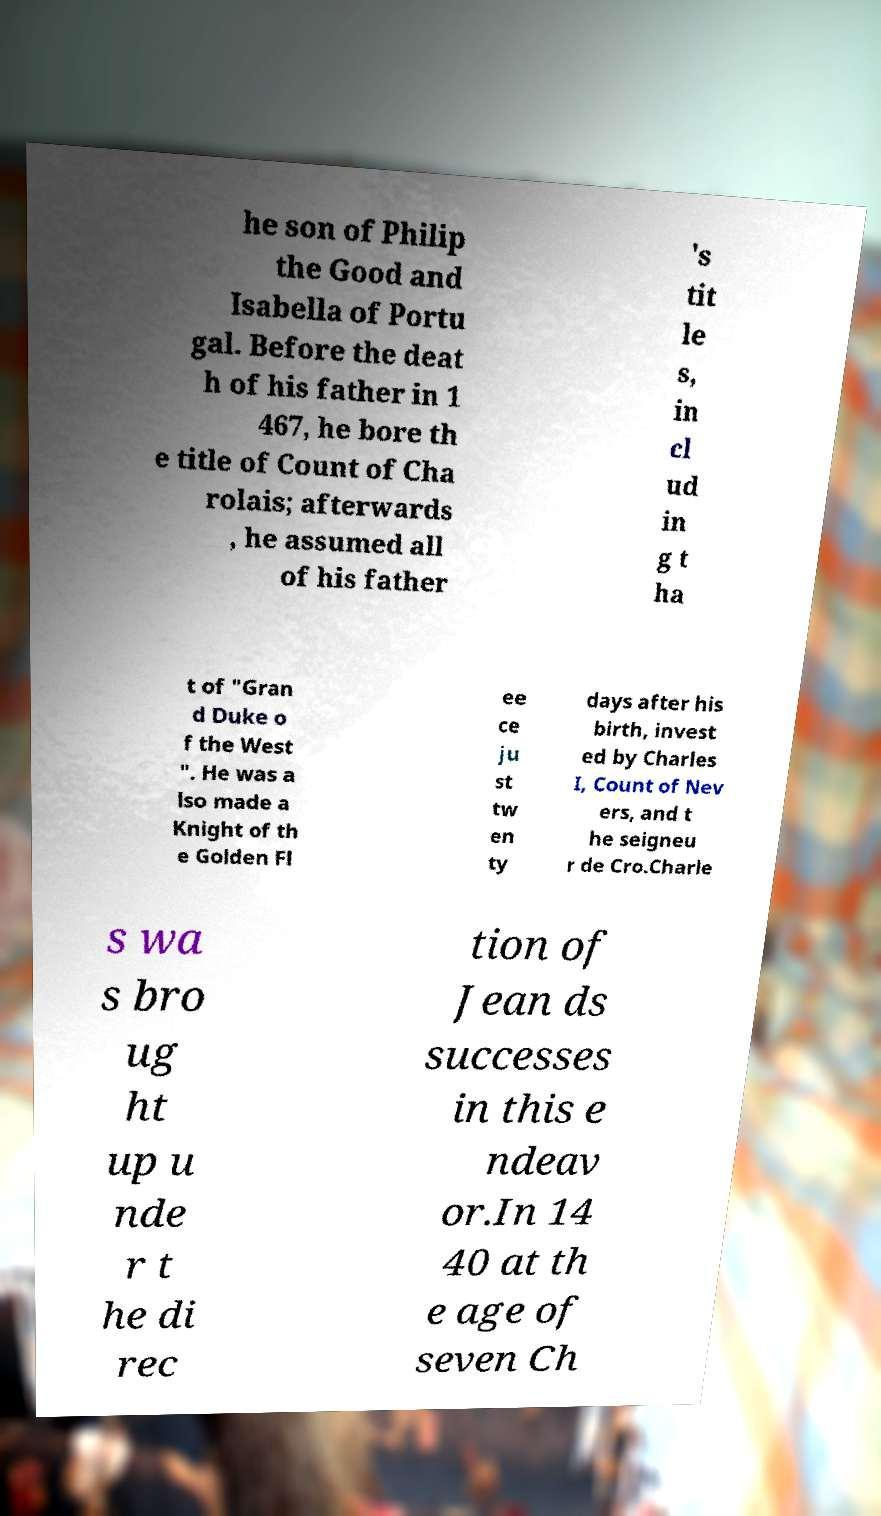Can you accurately transcribe the text from the provided image for me? he son of Philip the Good and Isabella of Portu gal. Before the deat h of his father in 1 467, he bore th e title of Count of Cha rolais; afterwards , he assumed all of his father 's tit le s, in cl ud in g t ha t of "Gran d Duke o f the West ". He was a lso made a Knight of th e Golden Fl ee ce ju st tw en ty days after his birth, invest ed by Charles I, Count of Nev ers, and t he seigneu r de Cro.Charle s wa s bro ug ht up u nde r t he di rec tion of Jean ds successes in this e ndeav or.In 14 40 at th e age of seven Ch 